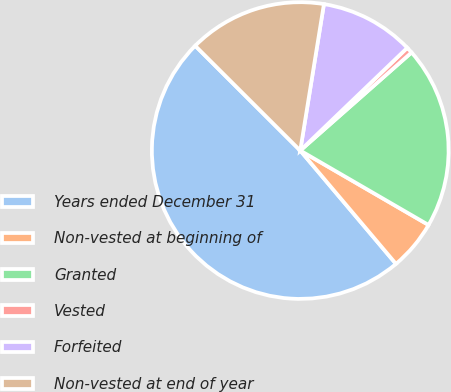Convert chart to OTSL. <chart><loc_0><loc_0><loc_500><loc_500><pie_chart><fcel>Years ended December 31<fcel>Non-vested at beginning of<fcel>Granted<fcel>Vested<fcel>Forfeited<fcel>Non-vested at end of year<nl><fcel>48.64%<fcel>5.47%<fcel>19.86%<fcel>0.68%<fcel>10.27%<fcel>15.07%<nl></chart> 